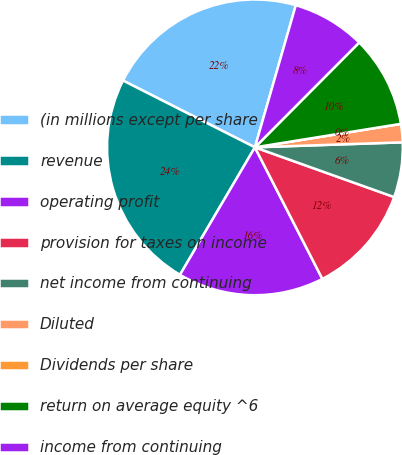Convert chart. <chart><loc_0><loc_0><loc_500><loc_500><pie_chart><fcel>(in millions except per share<fcel>revenue<fcel>operating profit<fcel>provision for taxes on income<fcel>net income from continuing<fcel>Diluted<fcel>Dividends per share<fcel>return on average equity ^6<fcel>income from continuing<nl><fcel>22.0%<fcel>24.0%<fcel>16.0%<fcel>12.0%<fcel>6.0%<fcel>2.0%<fcel>0.0%<fcel>10.0%<fcel>8.0%<nl></chart> 